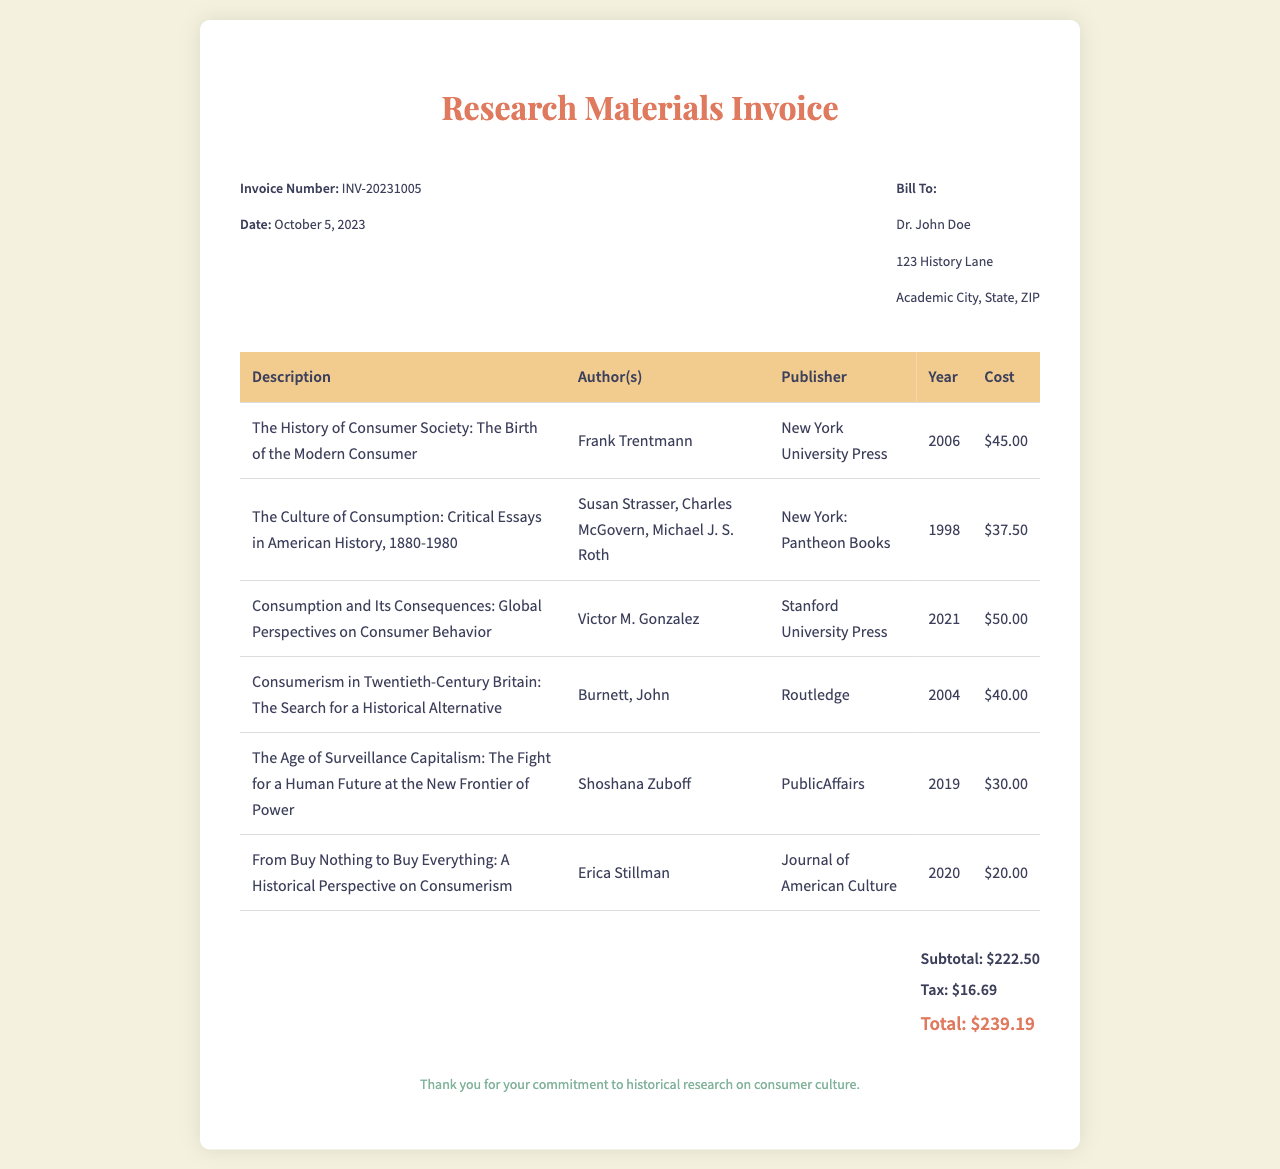What is the invoice number? The invoice number is listed prominently in the invoice details section.
Answer: INV-20231005 Who is the bill recipient? The recipient's name is mentioned in the bill to section of the invoice.
Answer: Dr. John Doe What is the total amount due? The total amount is calculated at the bottom of the invoice, combining the subtotal and tax.
Answer: $239.19 How many articles are listed in the invoice? The number of articles can be counted in the itemized table in the invoice.
Answer: 6 What year was "The Age of Surveillance Capitalism" published? The publication year is provided in the itemized costs section next to its title.
Answer: 2019 What is the subtotal amount before tax? The subtotal is specified in the total section of the invoice, excluding tax.
Answer: $222.50 Which publisher published "The Culture of Consumption"? The publisher's name is provided beside the title in the itemized section of the invoice.
Answer: Pantheon Books Who authored "From Buy Nothing to Buy Everything"? The author's name is included in the row corresponding to the title in the invoice.
Answer: Erica Stillman What is the total tax amount charged? The tax amount is specifically mentioned in the total section of the invoice.
Answer: $16.69 